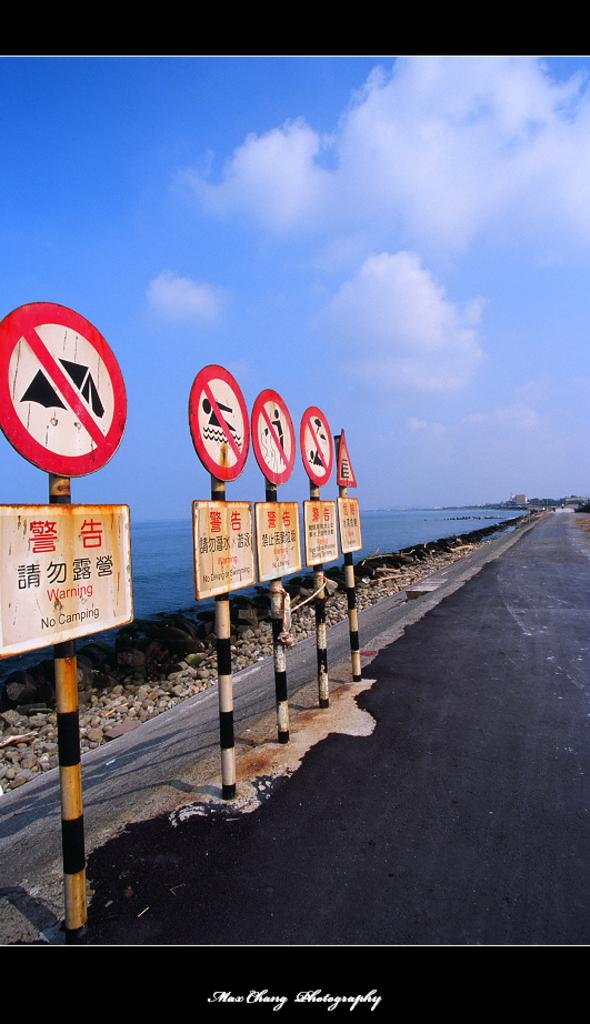<image>
Create a compact narrative representing the image presented. A series of road signs warn people in multiple languages that there is no camping allowed. 